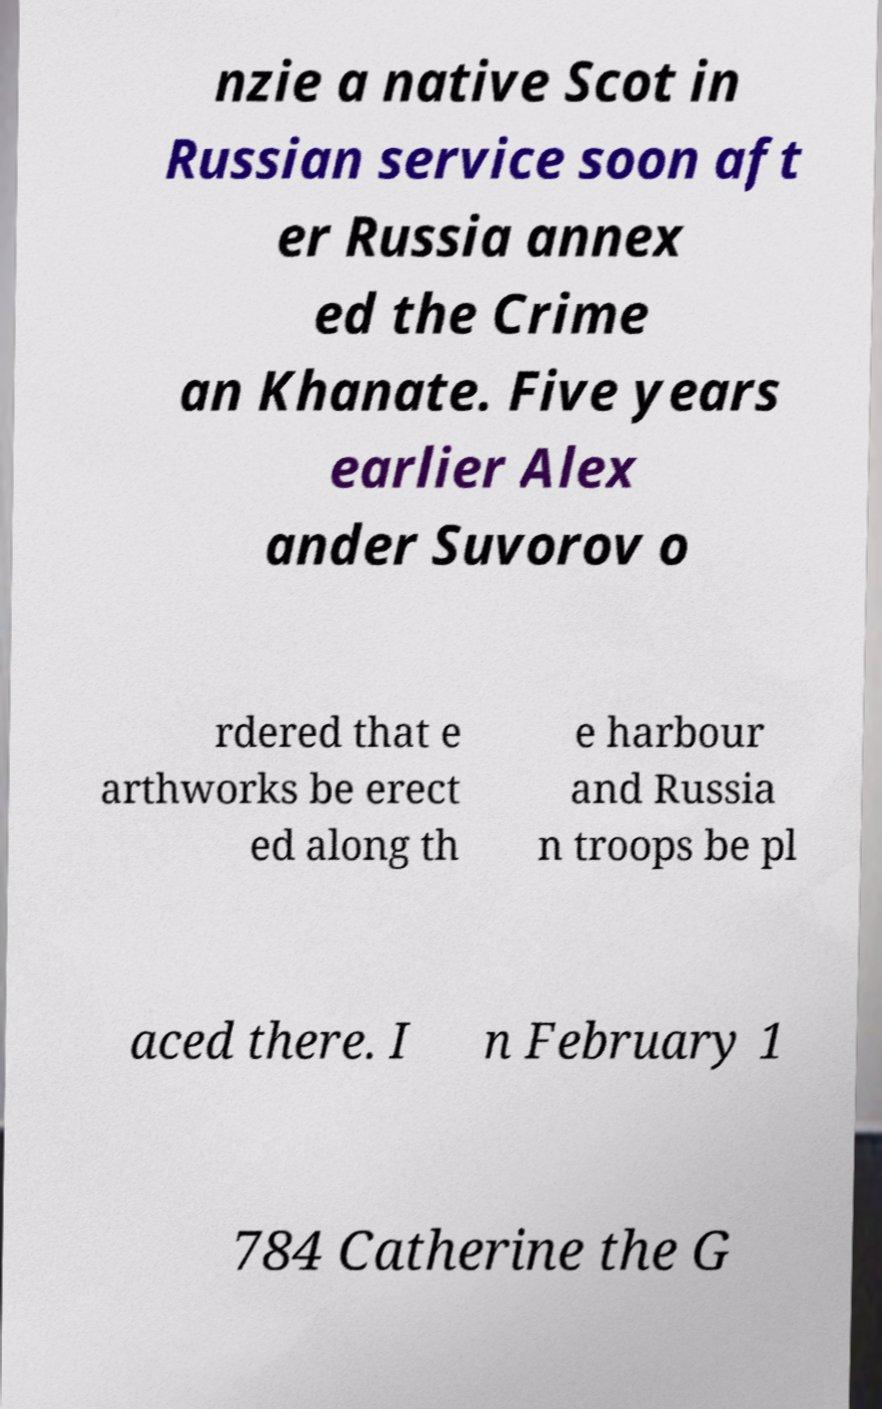Please identify and transcribe the text found in this image. nzie a native Scot in Russian service soon aft er Russia annex ed the Crime an Khanate. Five years earlier Alex ander Suvorov o rdered that e arthworks be erect ed along th e harbour and Russia n troops be pl aced there. I n February 1 784 Catherine the G 